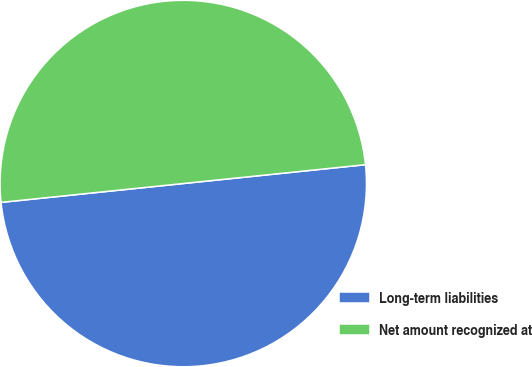Convert chart. <chart><loc_0><loc_0><loc_500><loc_500><pie_chart><fcel>Long-term liabilities<fcel>Net amount recognized at<nl><fcel>50.0%<fcel>50.0%<nl></chart> 